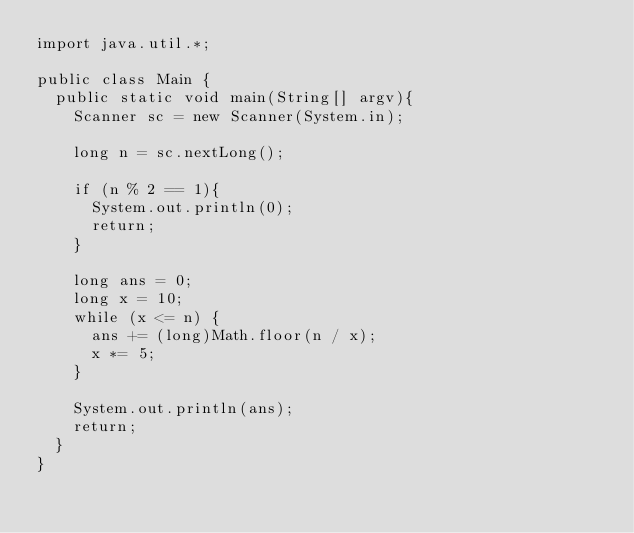<code> <loc_0><loc_0><loc_500><loc_500><_Java_>import java.util.*;

public class Main {
  public static void main(String[] argv){
    Scanner sc = new Scanner(System.in);

    long n = sc.nextLong();

    if (n % 2 == 1){
      System.out.println(0);
      return;
    }

    long ans = 0;
    long x = 10;
    while (x <= n) {
      ans += (long)Math.floor(n / x);
      x *= 5;
    }

    System.out.println(ans);
    return;
  }
}</code> 